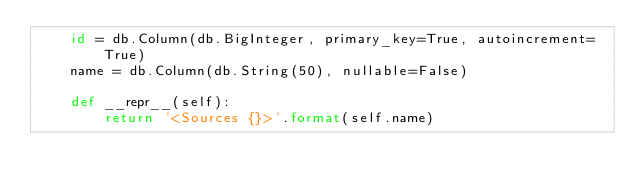<code> <loc_0><loc_0><loc_500><loc_500><_Python_>    id = db.Column(db.BigInteger, primary_key=True, autoincrement=True)
    name = db.Column(db.String(50), nullable=False)

    def __repr__(self):
        return '<Sources {}>'.format(self.name)</code> 